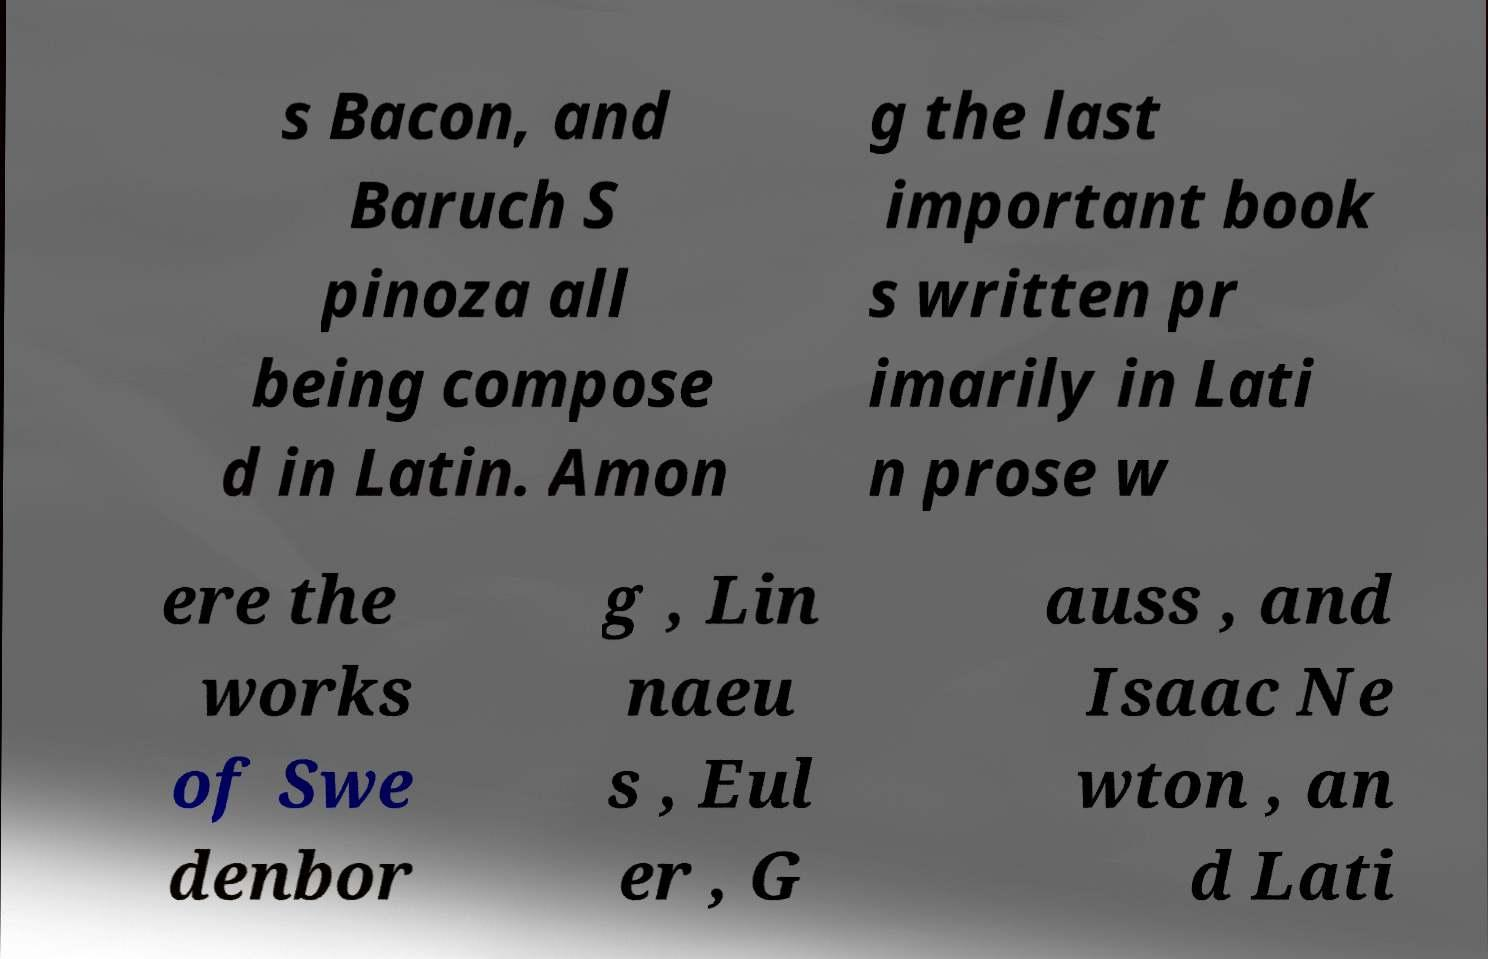There's text embedded in this image that I need extracted. Can you transcribe it verbatim? s Bacon, and Baruch S pinoza all being compose d in Latin. Amon g the last important book s written pr imarily in Lati n prose w ere the works of Swe denbor g , Lin naeu s , Eul er , G auss , and Isaac Ne wton , an d Lati 